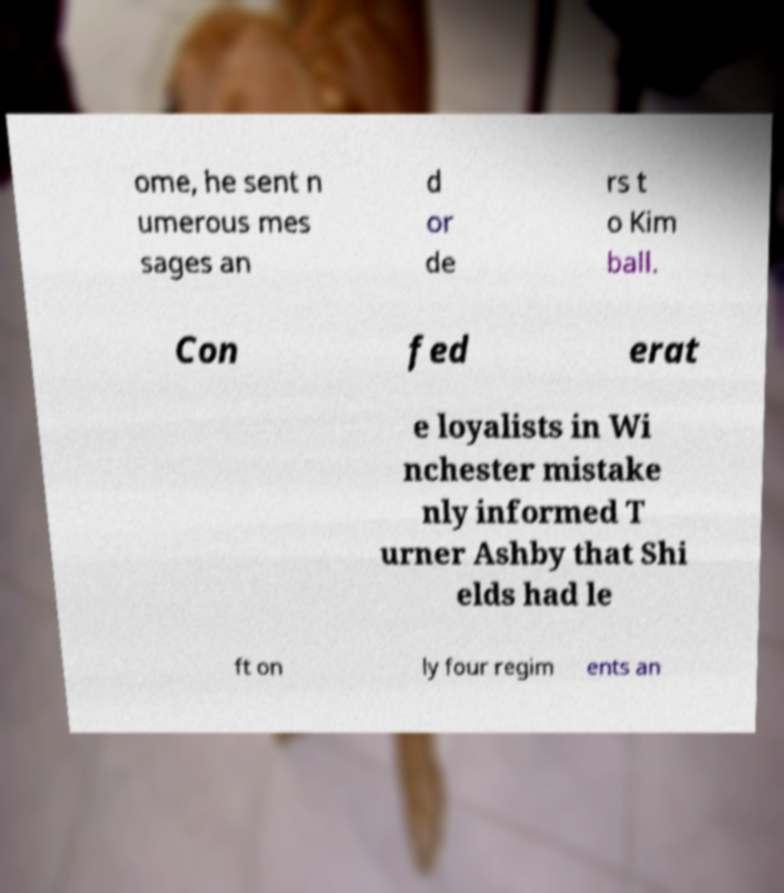Can you read and provide the text displayed in the image?This photo seems to have some interesting text. Can you extract and type it out for me? ome, he sent n umerous mes sages an d or de rs t o Kim ball. Con fed erat e loyalists in Wi nchester mistake nly informed T urner Ashby that Shi elds had le ft on ly four regim ents an 